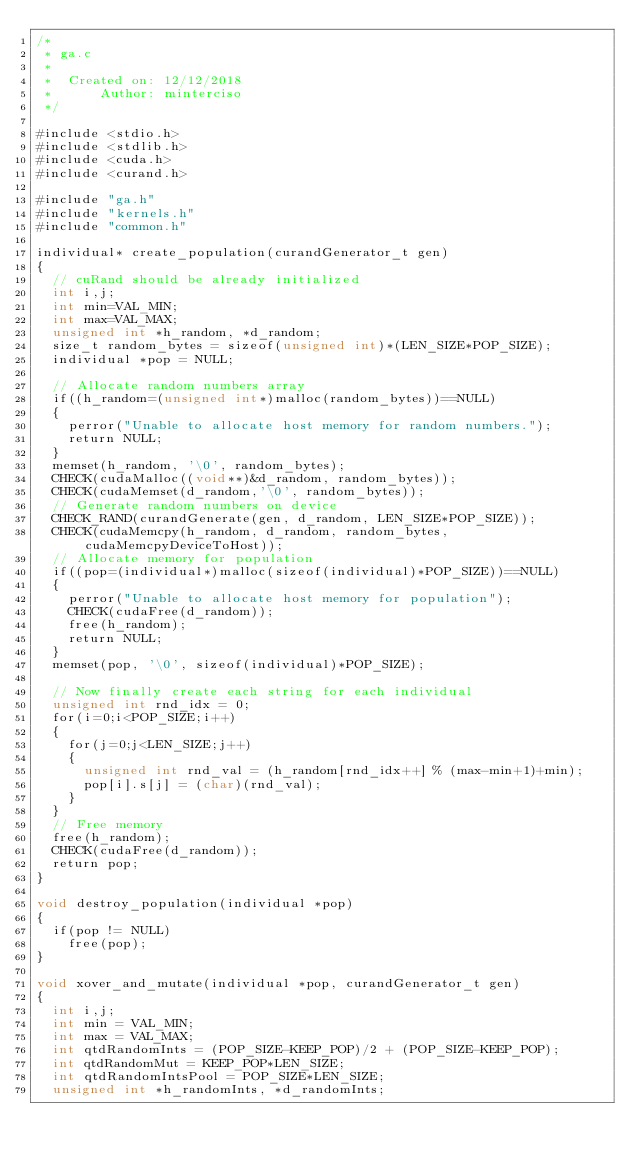Convert code to text. <code><loc_0><loc_0><loc_500><loc_500><_Cuda_>/*
 * ga.c
 *
 *  Created on: 12/12/2018
 *      Author: minterciso
 */

#include <stdio.h>
#include <stdlib.h>
#include <cuda.h>
#include <curand.h>

#include "ga.h"
#include "kernels.h"
#include "common.h"

individual* create_population(curandGenerator_t gen)
{
	// cuRand should be already initialized
	int i,j;
	int min=VAL_MIN;
	int max=VAL_MAX;
	unsigned int *h_random, *d_random;
	size_t random_bytes = sizeof(unsigned int)*(LEN_SIZE*POP_SIZE);
	individual *pop = NULL;

	// Allocate random numbers array
	if((h_random=(unsigned int*)malloc(random_bytes))==NULL)
	{
		perror("Unable to allocate host memory for random numbers.");
		return NULL;
	}
	memset(h_random, '\0', random_bytes);
	CHECK(cudaMalloc((void**)&d_random, random_bytes));
	CHECK(cudaMemset(d_random,'\0', random_bytes));
	// Generate random numbers on device
	CHECK_RAND(curandGenerate(gen, d_random, LEN_SIZE*POP_SIZE));
	CHECK(cudaMemcpy(h_random, d_random, random_bytes, cudaMemcpyDeviceToHost));
	// Allocate memory for population
	if((pop=(individual*)malloc(sizeof(individual)*POP_SIZE))==NULL)
	{
		perror("Unable to allocate host memory for population");
		CHECK(cudaFree(d_random));
		free(h_random);
		return NULL;
	}
	memset(pop, '\0', sizeof(individual)*POP_SIZE);

	// Now finally create each string for each individual
	unsigned int rnd_idx = 0;
	for(i=0;i<POP_SIZE;i++)
	{
		for(j=0;j<LEN_SIZE;j++)
		{
			unsigned int rnd_val = (h_random[rnd_idx++] % (max-min+1)+min);
			pop[i].s[j] = (char)(rnd_val);
		}
	}
	// Free memory
	free(h_random);
	CHECK(cudaFree(d_random));
	return pop;
}

void destroy_population(individual *pop)
{
	if(pop != NULL)
		free(pop);
}

void xover_and_mutate(individual *pop, curandGenerator_t gen)
{
	int i,j;
	int min = VAL_MIN;
	int max = VAL_MAX;
	int qtdRandomInts = (POP_SIZE-KEEP_POP)/2 + (POP_SIZE-KEEP_POP);
	int qtdRandomMut = KEEP_POP*LEN_SIZE;
	int qtdRandomIntsPool = POP_SIZE*LEN_SIZE;
	unsigned int *h_randomInts, *d_randomInts;</code> 